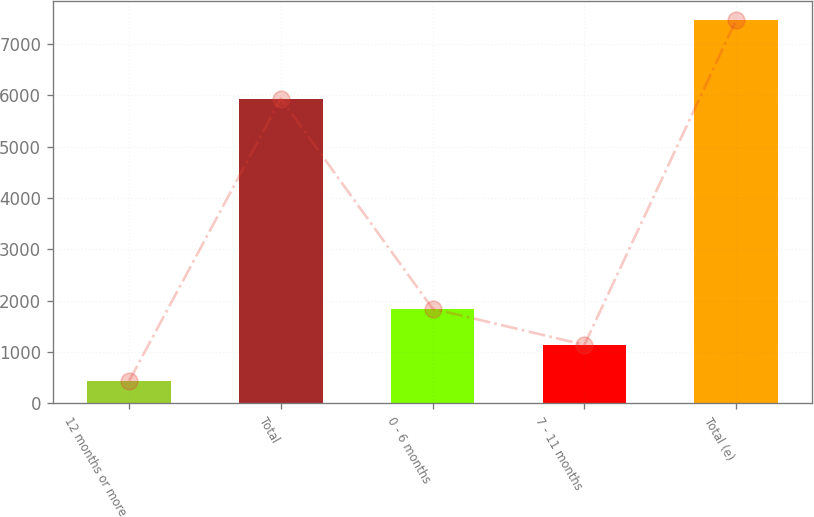Convert chart to OTSL. <chart><loc_0><loc_0><loc_500><loc_500><bar_chart><fcel>12 months or more<fcel>Total<fcel>0 - 6 months<fcel>7 - 11 months<fcel>Total (e)<nl><fcel>439<fcel>5940<fcel>1845.4<fcel>1142.2<fcel>7471<nl></chart> 